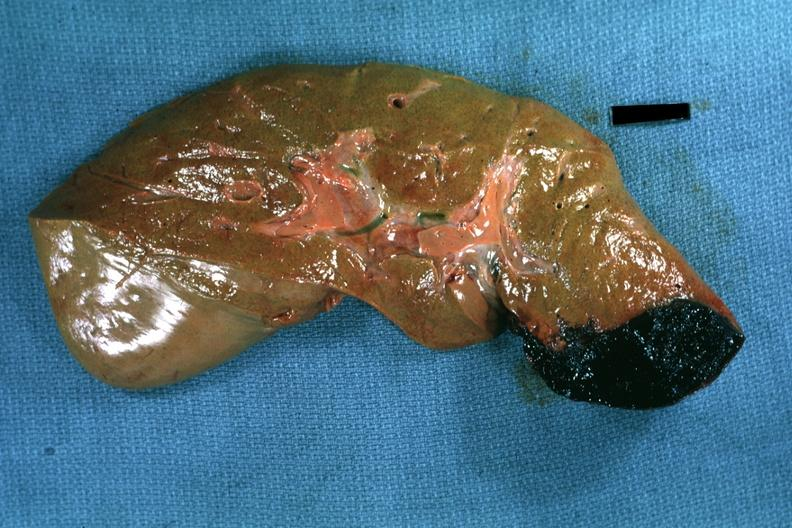s hepatobiliary present?
Answer the question using a single word or phrase. Yes 